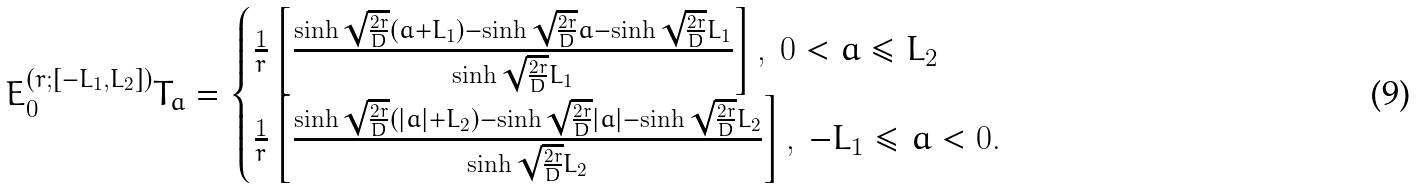Convert formula to latex. <formula><loc_0><loc_0><loc_500><loc_500>E _ { 0 } ^ { ( r ; [ - L _ { 1 } , L _ { 2 } ] ) } T _ { a } = \begin{cases} \frac { 1 } { r } \left [ \frac { \sinh \sqrt { \frac { 2 r } D } ( a + L _ { 1 } ) - \sinh \sqrt { \frac { 2 r } D } a - \sinh \sqrt { \frac { 2 r } D } L _ { 1 } } { \sinh \sqrt { \frac { 2 r } D } L _ { 1 } } \right ] , \ 0 < a \leq L _ { 2 } \\ \frac { 1 } { r } \left [ \frac { \sinh \sqrt { \frac { 2 r } D } ( | a | + L _ { 2 } ) - \sinh \sqrt { \frac { 2 r } D } | a | - \sinh \sqrt { \frac { 2 r } D } L _ { 2 } } { \sinh \sqrt { \frac { 2 r } D } L _ { 2 } } \right ] , \ - L _ { 1 } \leq a < 0 . \end{cases}</formula> 